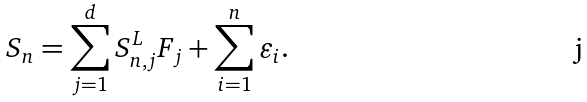Convert formula to latex. <formula><loc_0><loc_0><loc_500><loc_500>S _ { n } = \sum _ { j = 1 } ^ { d } S _ { n , j } ^ { L } F _ { j } + \sum _ { i = 1 } ^ { n } \varepsilon _ { i } .</formula> 